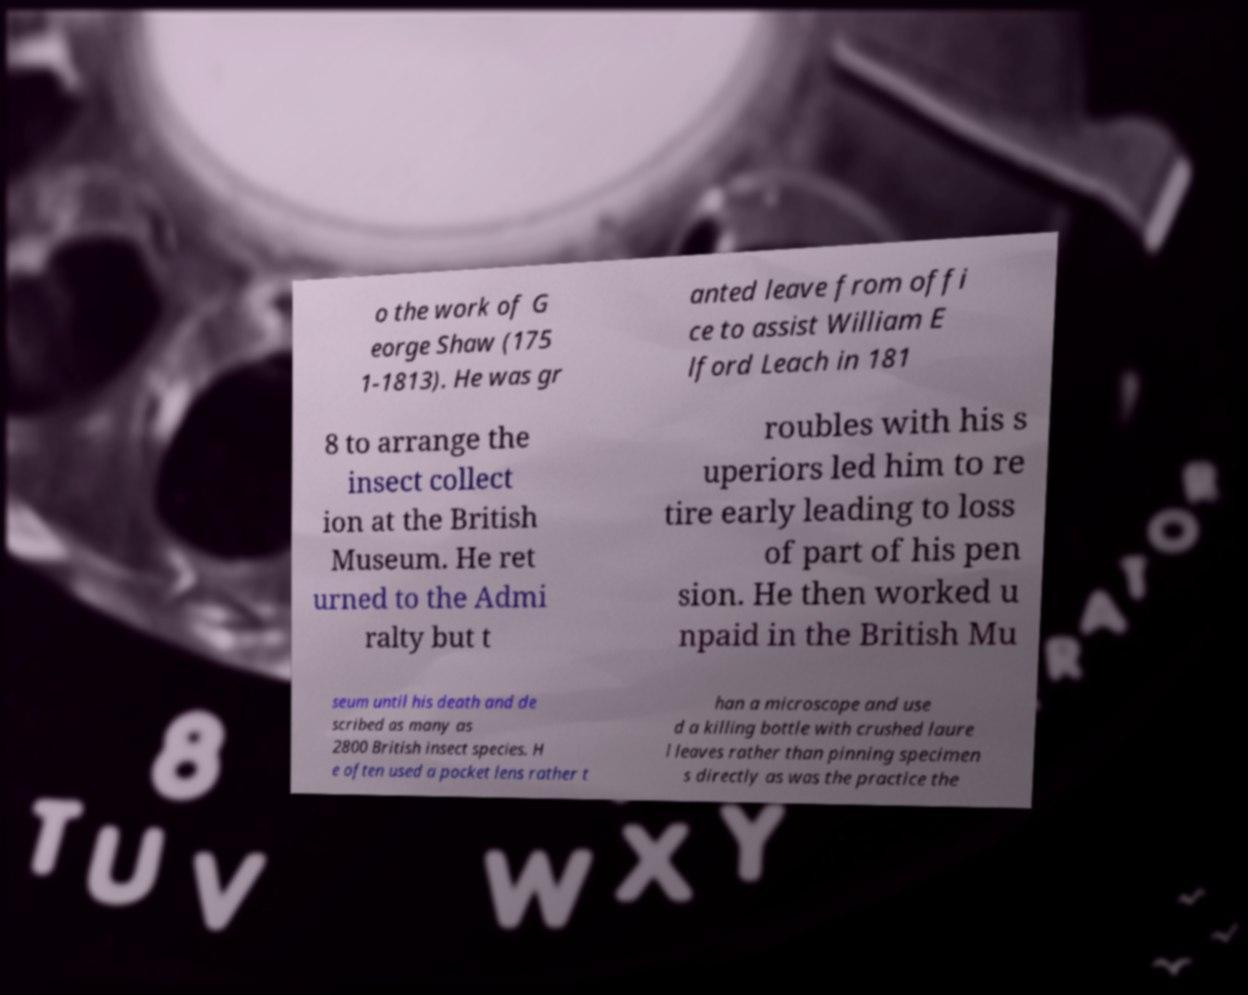Please identify and transcribe the text found in this image. o the work of G eorge Shaw (175 1-1813). He was gr anted leave from offi ce to assist William E lford Leach in 181 8 to arrange the insect collect ion at the British Museum. He ret urned to the Admi ralty but t roubles with his s uperiors led him to re tire early leading to loss of part of his pen sion. He then worked u npaid in the British Mu seum until his death and de scribed as many as 2800 British insect species. H e often used a pocket lens rather t han a microscope and use d a killing bottle with crushed laure l leaves rather than pinning specimen s directly as was the practice the 